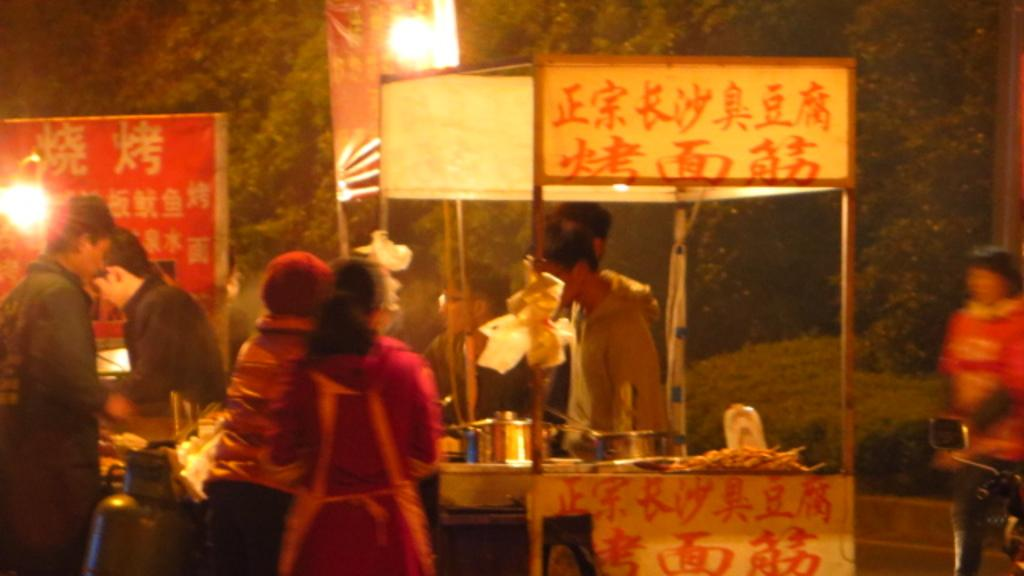What is the lighting condition in the image? The image was taken in the dark. How many food stalls can be seen in the image? There are two food stalls in the image. What is happening near the food stalls? There are people standing near the food stalls. What can be seen in the background of the image? There are trees and a street light in the background of the image. What type of kite is being flown by the people in the image? There is no kite present in the image; it was taken in the dark with two food stalls and people standing near them. What kind of plastic materials can be seen in the image? There is no specific mention of plastic materials in the image, as it focuses on the food stalls, people, and background elements. 